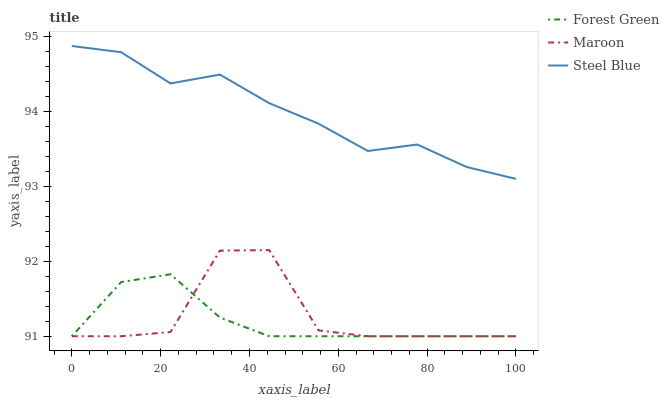Does Forest Green have the minimum area under the curve?
Answer yes or no. Yes. Does Steel Blue have the maximum area under the curve?
Answer yes or no. Yes. Does Maroon have the minimum area under the curve?
Answer yes or no. No. Does Maroon have the maximum area under the curve?
Answer yes or no. No. Is Forest Green the smoothest?
Answer yes or no. Yes. Is Maroon the roughest?
Answer yes or no. Yes. Is Steel Blue the smoothest?
Answer yes or no. No. Is Steel Blue the roughest?
Answer yes or no. No. Does Forest Green have the lowest value?
Answer yes or no. Yes. Does Steel Blue have the lowest value?
Answer yes or no. No. Does Steel Blue have the highest value?
Answer yes or no. Yes. Does Maroon have the highest value?
Answer yes or no. No. Is Maroon less than Steel Blue?
Answer yes or no. Yes. Is Steel Blue greater than Forest Green?
Answer yes or no. Yes. Does Forest Green intersect Maroon?
Answer yes or no. Yes. Is Forest Green less than Maroon?
Answer yes or no. No. Is Forest Green greater than Maroon?
Answer yes or no. No. Does Maroon intersect Steel Blue?
Answer yes or no. No. 